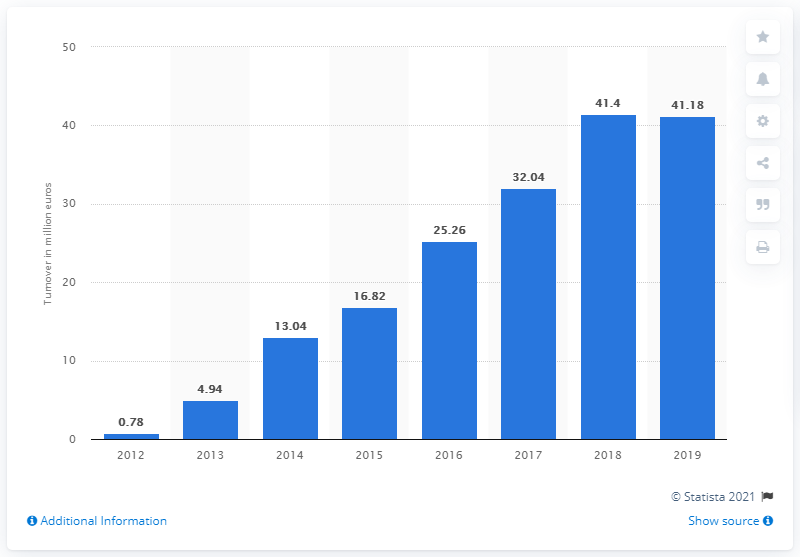Outline some significant characteristics in this image. Turnover of Vivre Deco SA in 2014 was 13.04. In 2016, the amount of euros was higher than in 2013 by 20.32 euros. There are more than 41 million euros in the last 2 years. The turnover of Vivre Deco SA in 2019 was 41.18. 